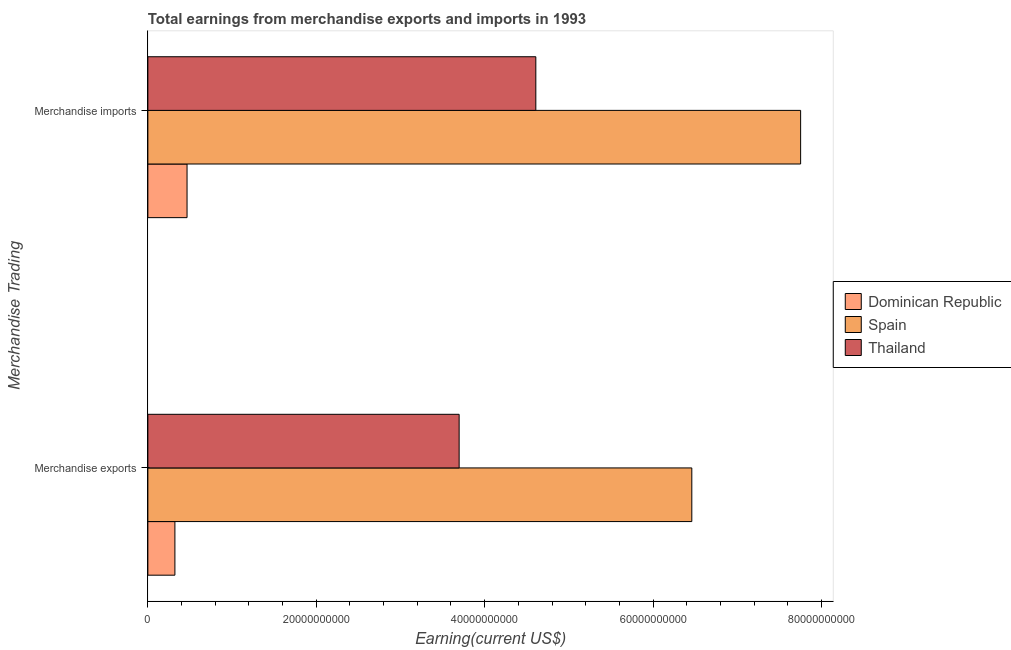How many bars are there on the 1st tick from the top?
Ensure brevity in your answer.  3. What is the earnings from merchandise imports in Thailand?
Your response must be concise. 4.61e+1. Across all countries, what is the maximum earnings from merchandise imports?
Your answer should be very brief. 7.75e+1. Across all countries, what is the minimum earnings from merchandise imports?
Make the answer very short. 4.65e+09. In which country was the earnings from merchandise exports maximum?
Ensure brevity in your answer.  Spain. In which country was the earnings from merchandise exports minimum?
Offer a very short reply. Dominican Republic. What is the total earnings from merchandise exports in the graph?
Give a very brief answer. 1.05e+11. What is the difference between the earnings from merchandise exports in Dominican Republic and that in Thailand?
Ensure brevity in your answer.  -3.38e+1. What is the difference between the earnings from merchandise imports in Spain and the earnings from merchandise exports in Dominican Republic?
Give a very brief answer. 7.43e+1. What is the average earnings from merchandise imports per country?
Offer a very short reply. 4.28e+1. What is the difference between the earnings from merchandise imports and earnings from merchandise exports in Dominican Republic?
Give a very brief answer. 1.44e+09. What is the ratio of the earnings from merchandise imports in Spain to that in Dominican Republic?
Your answer should be very brief. 16.66. What does the 3rd bar from the top in Merchandise exports represents?
Give a very brief answer. Dominican Republic. What does the 2nd bar from the bottom in Merchandise imports represents?
Provide a short and direct response. Spain. How many bars are there?
Your response must be concise. 6. How many countries are there in the graph?
Your answer should be compact. 3. Does the graph contain any zero values?
Your answer should be very brief. No. Where does the legend appear in the graph?
Your answer should be compact. Center right. How many legend labels are there?
Your answer should be very brief. 3. What is the title of the graph?
Provide a succinct answer. Total earnings from merchandise exports and imports in 1993. Does "Euro area" appear as one of the legend labels in the graph?
Give a very brief answer. No. What is the label or title of the X-axis?
Your answer should be compact. Earning(current US$). What is the label or title of the Y-axis?
Your response must be concise. Merchandise Trading. What is the Earning(current US$) of Dominican Republic in Merchandise exports?
Keep it short and to the point. 3.21e+09. What is the Earning(current US$) of Spain in Merchandise exports?
Offer a terse response. 6.46e+1. What is the Earning(current US$) in Thailand in Merchandise exports?
Give a very brief answer. 3.70e+1. What is the Earning(current US$) in Dominican Republic in Merchandise imports?
Provide a short and direct response. 4.65e+09. What is the Earning(current US$) in Spain in Merchandise imports?
Make the answer very short. 7.75e+1. What is the Earning(current US$) of Thailand in Merchandise imports?
Your answer should be very brief. 4.61e+1. Across all Merchandise Trading, what is the maximum Earning(current US$) of Dominican Republic?
Give a very brief answer. 4.65e+09. Across all Merchandise Trading, what is the maximum Earning(current US$) in Spain?
Your response must be concise. 7.75e+1. Across all Merchandise Trading, what is the maximum Earning(current US$) in Thailand?
Offer a very short reply. 4.61e+1. Across all Merchandise Trading, what is the minimum Earning(current US$) of Dominican Republic?
Your answer should be very brief. 3.21e+09. Across all Merchandise Trading, what is the minimum Earning(current US$) of Spain?
Keep it short and to the point. 6.46e+1. Across all Merchandise Trading, what is the minimum Earning(current US$) of Thailand?
Your response must be concise. 3.70e+1. What is the total Earning(current US$) of Dominican Republic in the graph?
Offer a terse response. 7.86e+09. What is the total Earning(current US$) in Spain in the graph?
Your response must be concise. 1.42e+11. What is the total Earning(current US$) in Thailand in the graph?
Ensure brevity in your answer.  8.30e+1. What is the difference between the Earning(current US$) in Dominican Republic in Merchandise exports and that in Merchandise imports?
Your response must be concise. -1.44e+09. What is the difference between the Earning(current US$) of Spain in Merchandise exports and that in Merchandise imports?
Provide a succinct answer. -1.29e+1. What is the difference between the Earning(current US$) in Thailand in Merchandise exports and that in Merchandise imports?
Offer a terse response. -9.11e+09. What is the difference between the Earning(current US$) of Dominican Republic in Merchandise exports and the Earning(current US$) of Spain in Merchandise imports?
Your answer should be compact. -7.43e+1. What is the difference between the Earning(current US$) of Dominican Republic in Merchandise exports and the Earning(current US$) of Thailand in Merchandise imports?
Provide a short and direct response. -4.29e+1. What is the difference between the Earning(current US$) in Spain in Merchandise exports and the Earning(current US$) in Thailand in Merchandise imports?
Keep it short and to the point. 1.85e+1. What is the average Earning(current US$) of Dominican Republic per Merchandise Trading?
Provide a short and direct response. 3.93e+09. What is the average Earning(current US$) in Spain per Merchandise Trading?
Keep it short and to the point. 7.11e+1. What is the average Earning(current US$) of Thailand per Merchandise Trading?
Offer a very short reply. 4.15e+1. What is the difference between the Earning(current US$) of Dominican Republic and Earning(current US$) of Spain in Merchandise exports?
Provide a succinct answer. -6.14e+1. What is the difference between the Earning(current US$) of Dominican Republic and Earning(current US$) of Thailand in Merchandise exports?
Give a very brief answer. -3.38e+1. What is the difference between the Earning(current US$) in Spain and Earning(current US$) in Thailand in Merchandise exports?
Provide a succinct answer. 2.76e+1. What is the difference between the Earning(current US$) in Dominican Republic and Earning(current US$) in Spain in Merchandise imports?
Give a very brief answer. -7.29e+1. What is the difference between the Earning(current US$) of Dominican Republic and Earning(current US$) of Thailand in Merchandise imports?
Provide a short and direct response. -4.14e+1. What is the difference between the Earning(current US$) of Spain and Earning(current US$) of Thailand in Merchandise imports?
Offer a very short reply. 3.14e+1. What is the ratio of the Earning(current US$) of Dominican Republic in Merchandise exports to that in Merchandise imports?
Your response must be concise. 0.69. What is the ratio of the Earning(current US$) in Thailand in Merchandise exports to that in Merchandise imports?
Ensure brevity in your answer.  0.8. What is the difference between the highest and the second highest Earning(current US$) in Dominican Republic?
Your answer should be very brief. 1.44e+09. What is the difference between the highest and the second highest Earning(current US$) in Spain?
Make the answer very short. 1.29e+1. What is the difference between the highest and the second highest Earning(current US$) in Thailand?
Keep it short and to the point. 9.11e+09. What is the difference between the highest and the lowest Earning(current US$) in Dominican Republic?
Your answer should be compact. 1.44e+09. What is the difference between the highest and the lowest Earning(current US$) of Spain?
Make the answer very short. 1.29e+1. What is the difference between the highest and the lowest Earning(current US$) of Thailand?
Provide a succinct answer. 9.11e+09. 